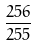Convert formula to latex. <formula><loc_0><loc_0><loc_500><loc_500>\frac { 2 5 6 } { 2 5 5 }</formula> 